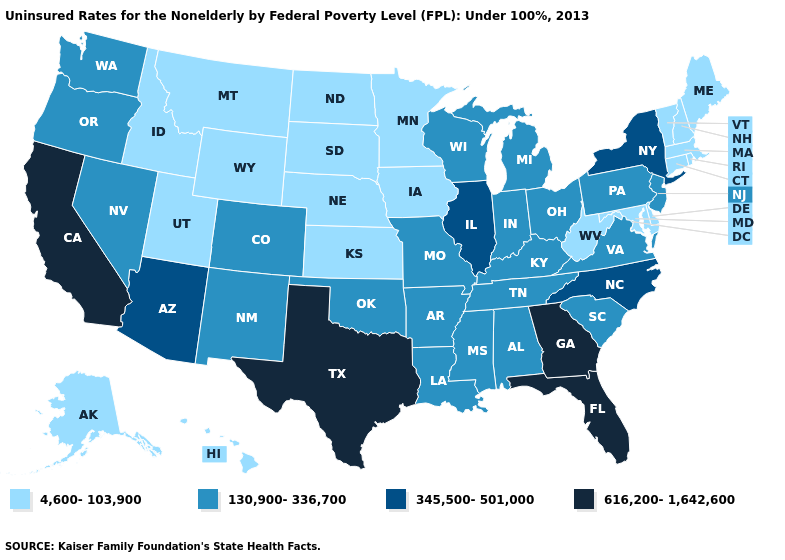What is the value of West Virginia?
Quick response, please. 4,600-103,900. Does New Mexico have the highest value in the USA?
Be succinct. No. What is the value of Delaware?
Write a very short answer. 4,600-103,900. What is the value of New Hampshire?
Keep it brief. 4,600-103,900. Is the legend a continuous bar?
Quick response, please. No. Which states have the lowest value in the West?
Keep it brief. Alaska, Hawaii, Idaho, Montana, Utah, Wyoming. What is the highest value in the MidWest ?
Give a very brief answer. 345,500-501,000. What is the value of Hawaii?
Write a very short answer. 4,600-103,900. Does Indiana have a higher value than New Jersey?
Be succinct. No. What is the highest value in states that border Wisconsin?
Give a very brief answer. 345,500-501,000. What is the value of North Carolina?
Give a very brief answer. 345,500-501,000. Name the states that have a value in the range 4,600-103,900?
Write a very short answer. Alaska, Connecticut, Delaware, Hawaii, Idaho, Iowa, Kansas, Maine, Maryland, Massachusetts, Minnesota, Montana, Nebraska, New Hampshire, North Dakota, Rhode Island, South Dakota, Utah, Vermont, West Virginia, Wyoming. Name the states that have a value in the range 616,200-1,642,600?
Concise answer only. California, Florida, Georgia, Texas. Name the states that have a value in the range 345,500-501,000?
Keep it brief. Arizona, Illinois, New York, North Carolina. 